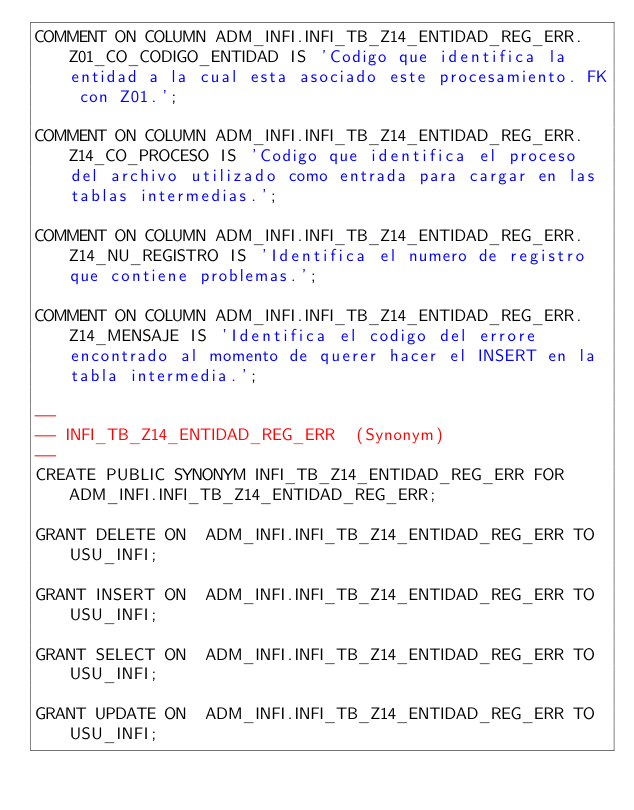Convert code to text. <code><loc_0><loc_0><loc_500><loc_500><_SQL_>COMMENT ON COLUMN ADM_INFI.INFI_TB_Z14_ENTIDAD_REG_ERR.Z01_CO_CODIGO_ENTIDAD IS 'Codigo que identifica la entidad a la cual esta asociado este procesamiento. FK con Z01.';

COMMENT ON COLUMN ADM_INFI.INFI_TB_Z14_ENTIDAD_REG_ERR.Z14_CO_PROCESO IS 'Codigo que identifica el proceso del archivo utilizado como entrada para cargar en las tablas intermedias.';

COMMENT ON COLUMN ADM_INFI.INFI_TB_Z14_ENTIDAD_REG_ERR.Z14_NU_REGISTRO IS 'Identifica el numero de registro que contiene problemas.';

COMMENT ON COLUMN ADM_INFI.INFI_TB_Z14_ENTIDAD_REG_ERR.Z14_MENSAJE IS 'Identifica el codigo del errore encontrado al momento de querer hacer el INSERT en la tabla intermedia.';

--
-- INFI_TB_Z14_ENTIDAD_REG_ERR  (Synonym) 
--
CREATE PUBLIC SYNONYM INFI_TB_Z14_ENTIDAD_REG_ERR FOR ADM_INFI.INFI_TB_Z14_ENTIDAD_REG_ERR;

GRANT DELETE ON  ADM_INFI.INFI_TB_Z14_ENTIDAD_REG_ERR TO USU_INFI;

GRANT INSERT ON  ADM_INFI.INFI_TB_Z14_ENTIDAD_REG_ERR TO USU_INFI;

GRANT SELECT ON  ADM_INFI.INFI_TB_Z14_ENTIDAD_REG_ERR TO USU_INFI;

GRANT UPDATE ON  ADM_INFI.INFI_TB_Z14_ENTIDAD_REG_ERR TO USU_INFI;

</code> 